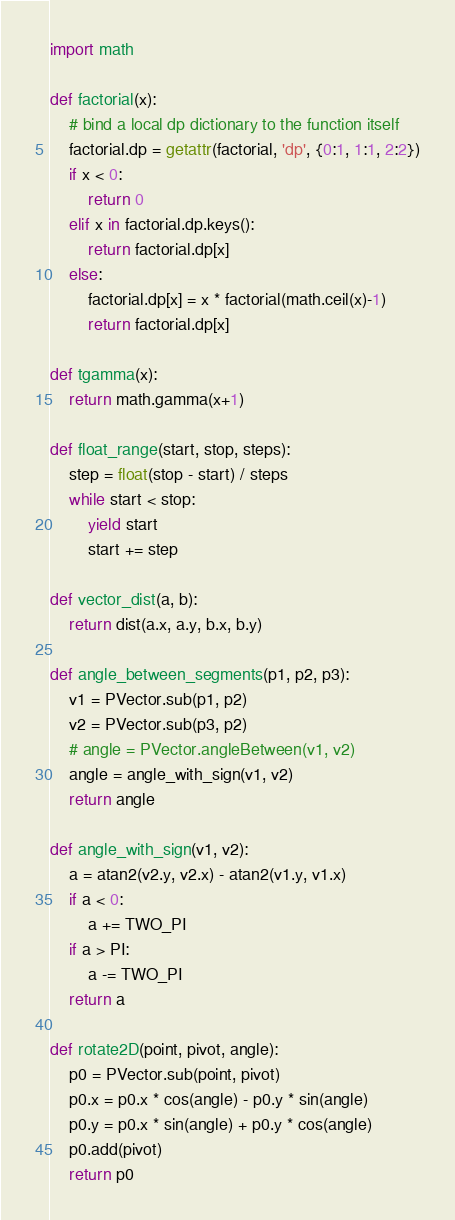<code> <loc_0><loc_0><loc_500><loc_500><_Python_>import math

def factorial(x):
    # bind a local dp dictionary to the function itself
    factorial.dp = getattr(factorial, 'dp', {0:1, 1:1, 2:2})
    if x < 0:
        return 0
    elif x in factorial.dp.keys():
        return factorial.dp[x]
    else:
        factorial.dp[x] = x * factorial(math.ceil(x)-1)
        return factorial.dp[x]

def tgamma(x):
    return math.gamma(x+1)

def float_range(start, stop, steps):
    step = float(stop - start) / steps
    while start < stop:
        yield start
        start += step

def vector_dist(a, b):
    return dist(a.x, a.y, b.x, b.y)

def angle_between_segments(p1, p2, p3):
    v1 = PVector.sub(p1, p2)
    v2 = PVector.sub(p3, p2)
    # angle = PVector.angleBetween(v1, v2)
    angle = angle_with_sign(v1, v2)
    return angle

def angle_with_sign(v1, v2):
    a = atan2(v2.y, v2.x) - atan2(v1.y, v1.x)
    if a < 0:
        a += TWO_PI
    if a > PI:
        a -= TWO_PI
    return a

def rotate2D(point, pivot, angle):
    p0 = PVector.sub(point, pivot)
    p0.x = p0.x * cos(angle) - p0.y * sin(angle)
    p0.y = p0.x * sin(angle) + p0.y * cos(angle)
    p0.add(pivot)
    return p0
</code> 